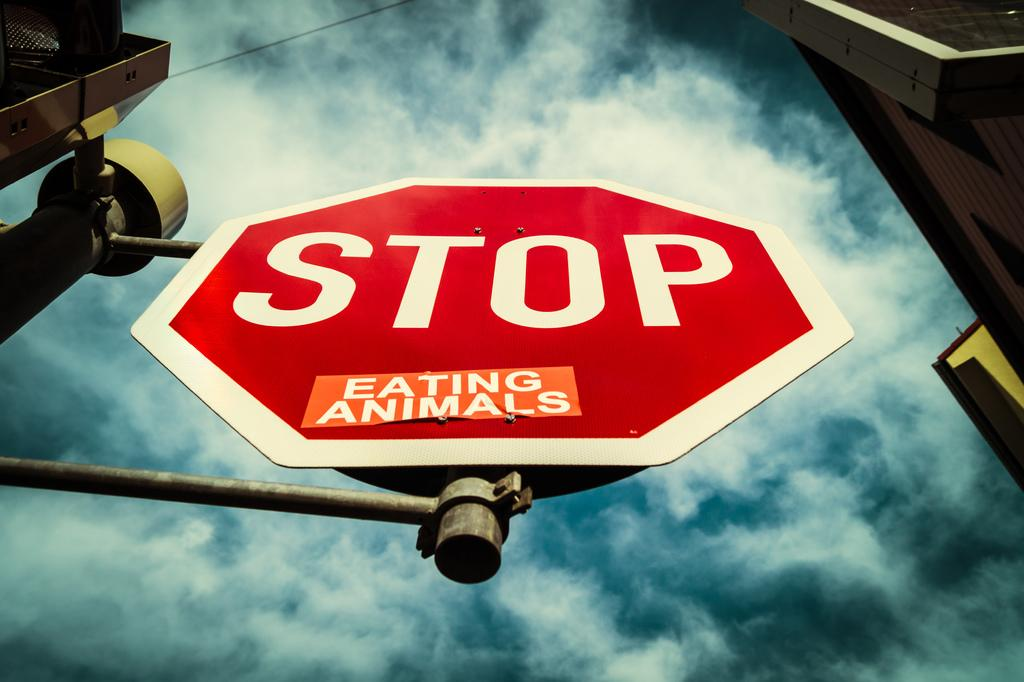<image>
Present a compact description of the photo's key features. Vegans probably posted this note on a stop sign about eating animals. 